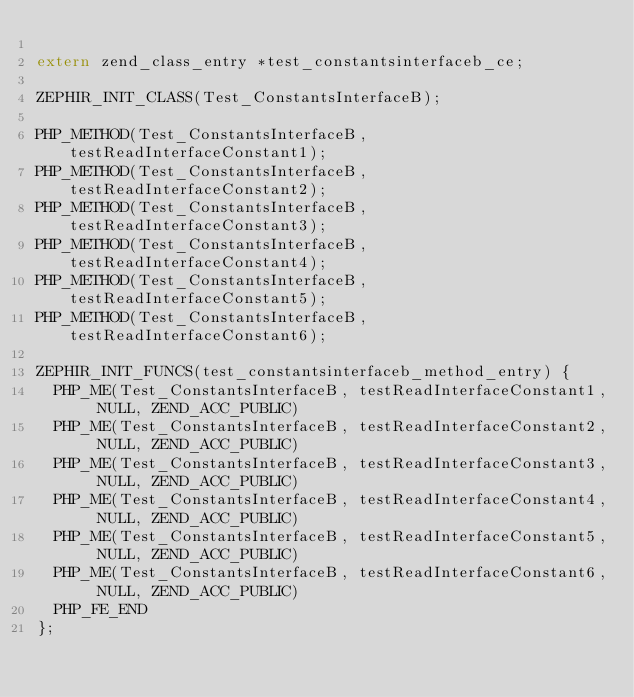<code> <loc_0><loc_0><loc_500><loc_500><_C_>
extern zend_class_entry *test_constantsinterfaceb_ce;

ZEPHIR_INIT_CLASS(Test_ConstantsInterfaceB);

PHP_METHOD(Test_ConstantsInterfaceB, testReadInterfaceConstant1);
PHP_METHOD(Test_ConstantsInterfaceB, testReadInterfaceConstant2);
PHP_METHOD(Test_ConstantsInterfaceB, testReadInterfaceConstant3);
PHP_METHOD(Test_ConstantsInterfaceB, testReadInterfaceConstant4);
PHP_METHOD(Test_ConstantsInterfaceB, testReadInterfaceConstant5);
PHP_METHOD(Test_ConstantsInterfaceB, testReadInterfaceConstant6);

ZEPHIR_INIT_FUNCS(test_constantsinterfaceb_method_entry) {
	PHP_ME(Test_ConstantsInterfaceB, testReadInterfaceConstant1, NULL, ZEND_ACC_PUBLIC)
	PHP_ME(Test_ConstantsInterfaceB, testReadInterfaceConstant2, NULL, ZEND_ACC_PUBLIC)
	PHP_ME(Test_ConstantsInterfaceB, testReadInterfaceConstant3, NULL, ZEND_ACC_PUBLIC)
	PHP_ME(Test_ConstantsInterfaceB, testReadInterfaceConstant4, NULL, ZEND_ACC_PUBLIC)
	PHP_ME(Test_ConstantsInterfaceB, testReadInterfaceConstant5, NULL, ZEND_ACC_PUBLIC)
	PHP_ME(Test_ConstantsInterfaceB, testReadInterfaceConstant6, NULL, ZEND_ACC_PUBLIC)
  PHP_FE_END
};
</code> 